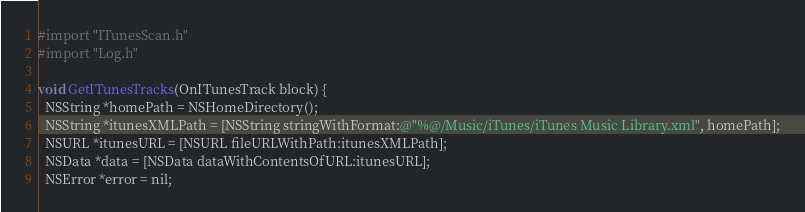Convert code to text. <code><loc_0><loc_0><loc_500><loc_500><_ObjectiveC_>#import "ITunesScan.h"
#import "Log.h"

void GetITunesTracks(OnITunesTrack block) {
  NSString *homePath = NSHomeDirectory();
  NSString *itunesXMLPath = [NSString stringWithFormat:@"%@/Music/iTunes/iTunes Music Library.xml", homePath];
  NSURL *itunesURL = [NSURL fileURLWithPath:itunesXMLPath];
  NSData *data = [NSData dataWithContentsOfURL:itunesURL];
  NSError *error = nil;
</code> 